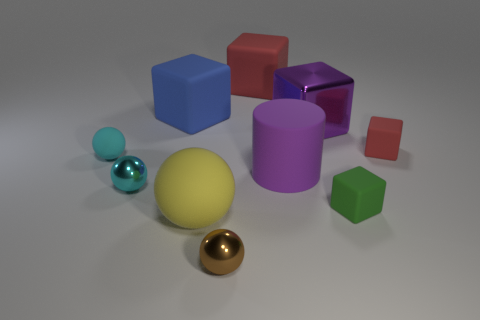Subtract all tiny rubber balls. How many balls are left? 3 Subtract all cyan cylinders. How many red blocks are left? 2 Subtract all yellow spheres. How many spheres are left? 3 Subtract 2 balls. How many balls are left? 2 Subtract all spheres. How many objects are left? 6 Subtract all cyan cubes. Subtract all red balls. How many cubes are left? 5 Subtract all blue objects. Subtract all tiny cyan metal balls. How many objects are left? 8 Add 3 big balls. How many big balls are left? 4 Add 7 cyan matte blocks. How many cyan matte blocks exist? 7 Subtract 1 green cubes. How many objects are left? 9 